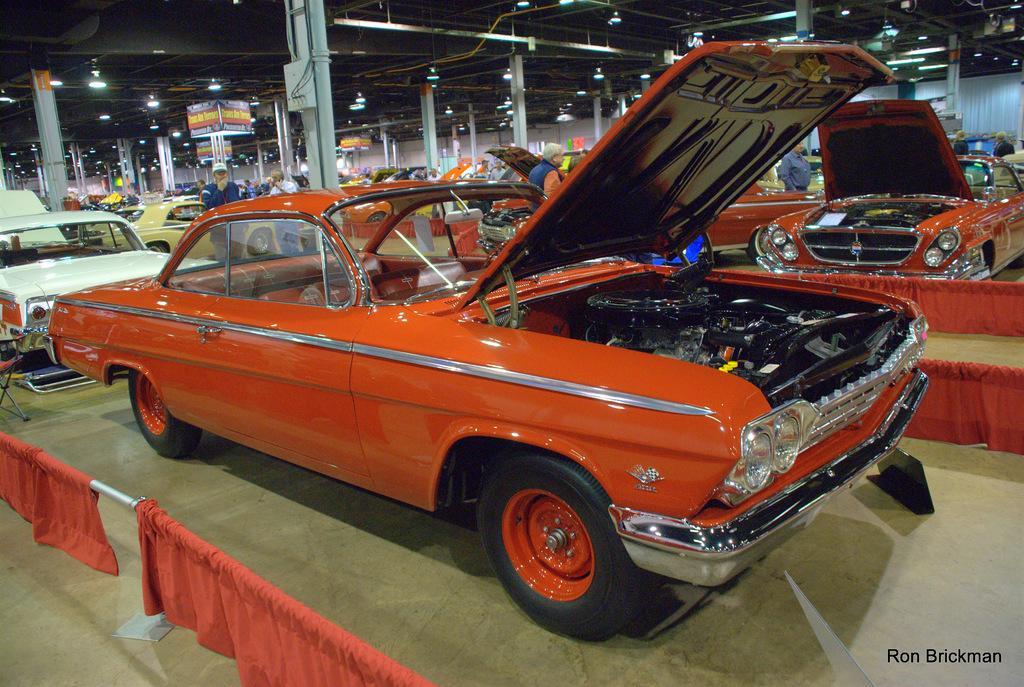Please provide a concise description of this image. In this image, there are a few vehicles and people. We can see some pillars and lights. We can see the ground with objects. We can also see a chair on the left. We can see the shed at the top. We can also see some text on the bottom right corner. We can see some poles with red colored cloth. 